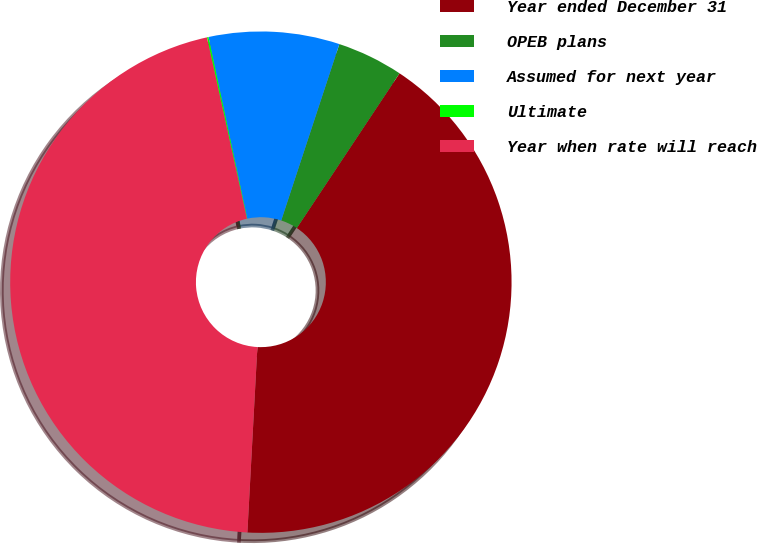Convert chart. <chart><loc_0><loc_0><loc_500><loc_500><pie_chart><fcel>Year ended December 31<fcel>OPEB plans<fcel>Assumed for next year<fcel>Ultimate<fcel>Year when rate will reach<nl><fcel>41.53%<fcel>4.26%<fcel>8.42%<fcel>0.1%<fcel>45.69%<nl></chart> 